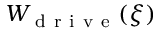Convert formula to latex. <formula><loc_0><loc_0><loc_500><loc_500>W _ { d r i v e } ( \xi )</formula> 